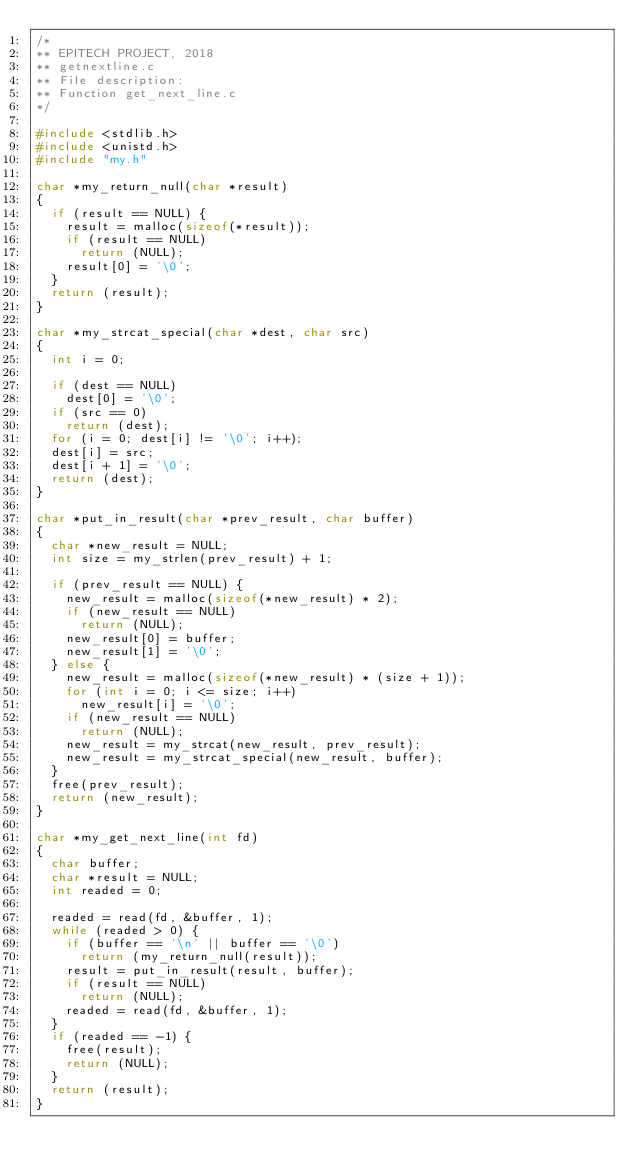<code> <loc_0><loc_0><loc_500><loc_500><_C_>/*
** EPITECH PROJECT, 2018
** getnextline.c
** File description:
** Function get_next_line.c
*/

#include <stdlib.h>
#include <unistd.h>
#include "my.h"

char *my_return_null(char *result)
{
	if (result == NULL) {
		result = malloc(sizeof(*result));
		if (result == NULL)
			return (NULL);
		result[0] = '\0';
	}
	return (result);
}

char *my_strcat_special(char *dest, char src)
{
	int i = 0;

	if (dest == NULL)
		dest[0] = '\0';
	if (src == 0)
		return (dest);
	for (i = 0; dest[i] != '\0'; i++);
	dest[i] = src;
	dest[i + 1] = '\0';
	return (dest);
}

char *put_in_result(char *prev_result, char buffer)
{
	char *new_result = NULL;
	int size = my_strlen(prev_result) + 1;

	if (prev_result == NULL) {
		new_result = malloc(sizeof(*new_result) * 2);
		if (new_result == NULL)
			return (NULL);
		new_result[0] = buffer;
		new_result[1] = '\0';
	} else {
		new_result = malloc(sizeof(*new_result) * (size + 1));
		for (int i = 0; i <= size; i++)
			new_result[i] = '\0';
		if (new_result == NULL)
			return (NULL);
		new_result = my_strcat(new_result, prev_result);
		new_result = my_strcat_special(new_result, buffer);
	}
	free(prev_result);
	return (new_result);
}

char *my_get_next_line(int fd)
{
	char buffer;
	char *result = NULL;
	int readed = 0;

	readed = read(fd, &buffer, 1);
	while (readed > 0) {
		if (buffer == '\n' || buffer == '\0')
			return (my_return_null(result));
		result = put_in_result(result, buffer);
		if (result == NULL)
			return (NULL);
		readed = read(fd, &buffer, 1);
	}
	if (readed == -1) {
		free(result);
		return (NULL);
	}
	return (result);
}
</code> 